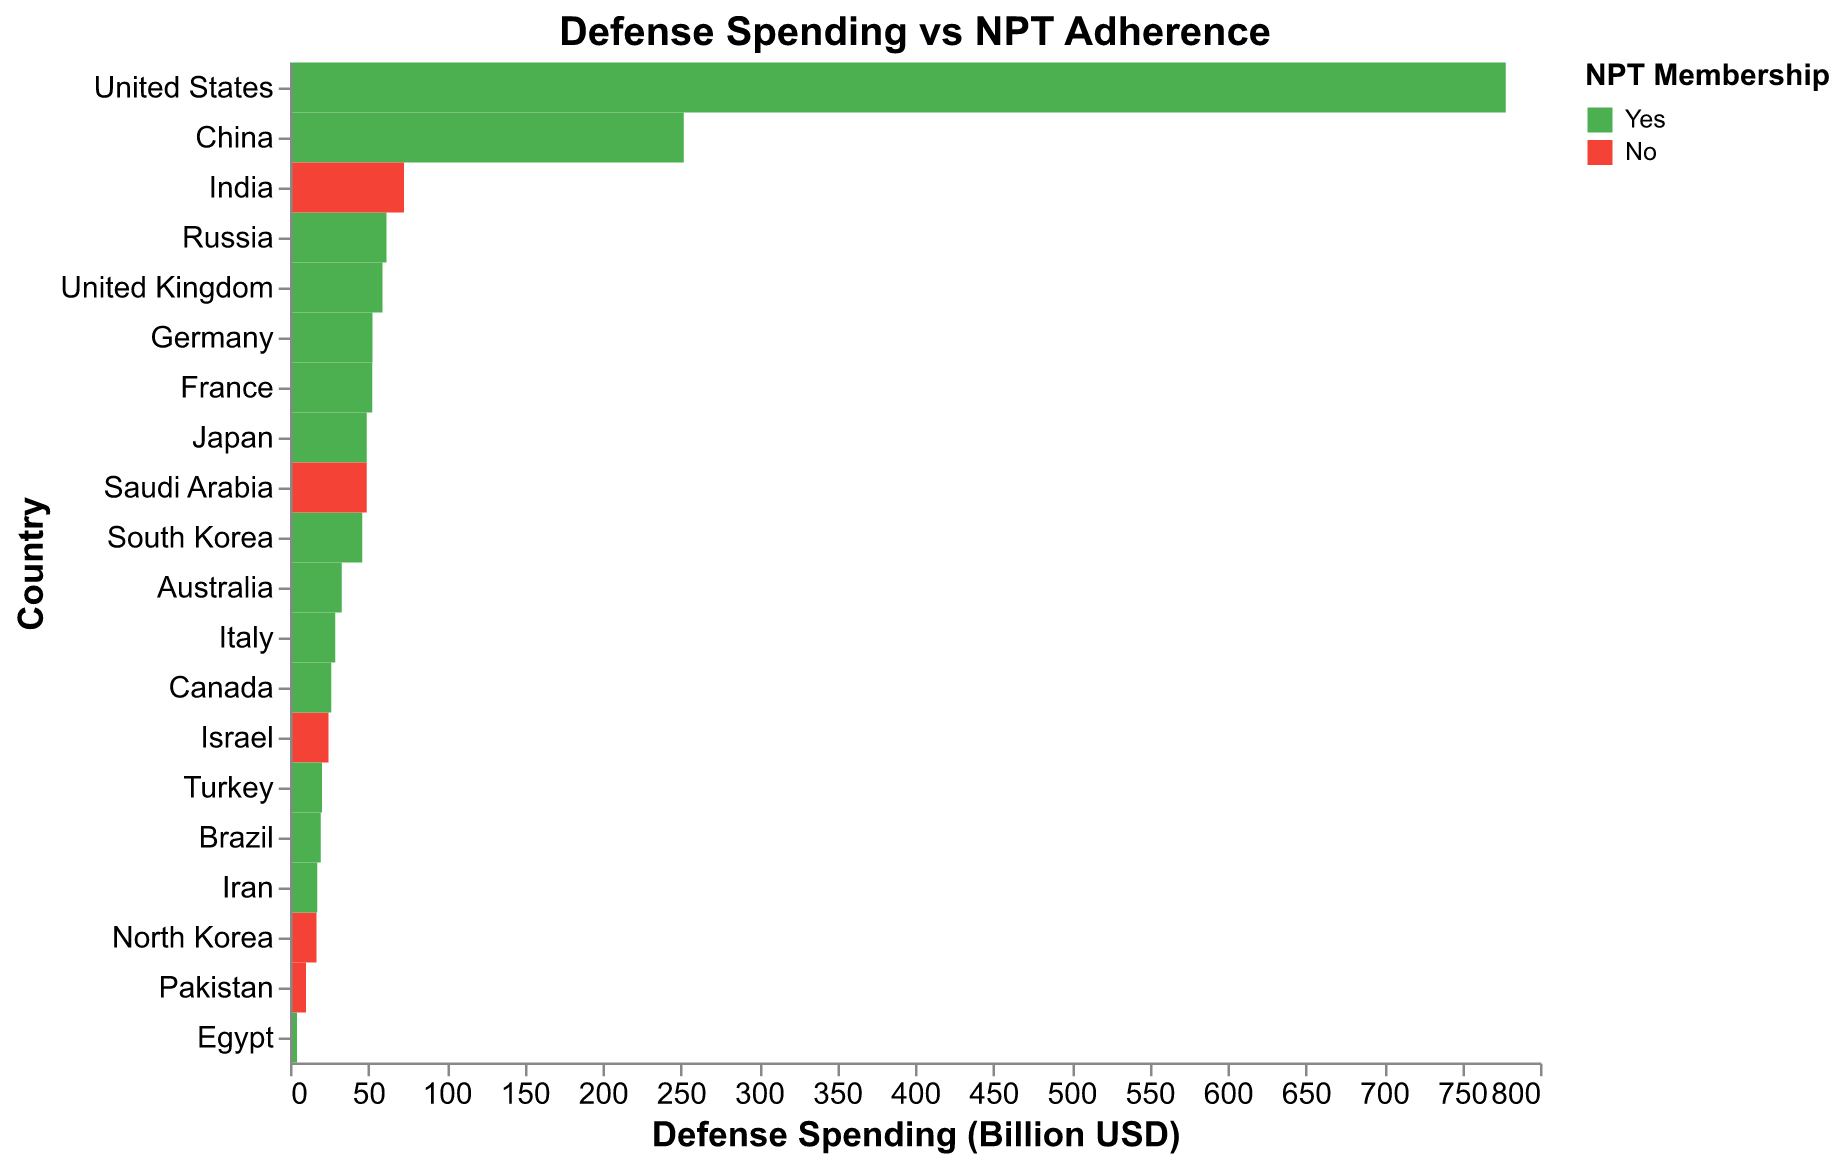What's the title of the figure? The title is specified at the top of the figure.
Answer: Defense Spending vs NPT Adherence Which country has the highest defense spending? The country with the highest value for the "Defense Spending (Billion USD)" on the x-axis is the United States.
Answer: United States How many countries in the figure are non-members of the NPT? The figure uses color to indicate NPT Membership. Countries with "No" NPT membership are in a different color (red). By counting these, we see there are five such countries: India, Pakistan, Israel, North Korea, and Saudi Arabia.
Answer: 5 Which country with NPT membership has the lowest defense spending? Among the countries in green color (indicating "Yes" for NPT Membership), the one with the lowest value on the x-axis is Egypt with 4.4 Billion USD.
Answer: Egypt Compare the defense spending of India and Brazil. Which country spends more? By locating India and Brazil on the y-axis and comparing their corresponding values on the x-axis, we see that India (72.9 Billion USD) spends more than Brazil (19.7 Billion USD).
Answer: India Which non-NPT member country spends approximately 50 Billion USD on defense? We identify non-NPT member countries by their red color. Among these, Saudi Arabia is the country with approximately 49.1 Billion USD in defense spending.
Answer: Saudi Arabia What's the average defense spending of countries that have signed the Additional Protocol? Countries that signed the Additional Protocol are highlighted in the tooltip. By summing the defense spending of these countries (778+52.7+59.2+52.8+49.1+46.3+33.1+26.4+28.9) and dividing by their count (9 countries), we get the average: (778+52.7+59.2+52.8+49.1+46.3+33.1+26.4+28.9)/9 = 125.05 Billion USD approximately.
Answer: 125.05 Billion USD Are there any countries that are members of the NPT but have not signed the Additional Protocol? By examining the tooltip details of each country in green, we see that China, Russia, Brazil, Iran, Egypt, and Turkey are marked "Yes" for NPT Membership but "No" for "Additional Protocol Signed".
Answer: Yes What proportion of NPT member countries have signed the Comprehensive Safeguards? All countries with "Yes" under "NPT Membership" also show "Yes" under "Comprehensive Safeguards". Therefore, 100% of NPT member countries have signed the Comprehensive Safeguards.
Answer: 100% Which country has similar defense spending to Canada but is not a member of the NPT? From the figure, Saudi Arabia (49.1 Billion USD) has a similar defense spending to Canada (26.4 Billion USD) but is not an NPT member.
Answer: Saudi Arabia 